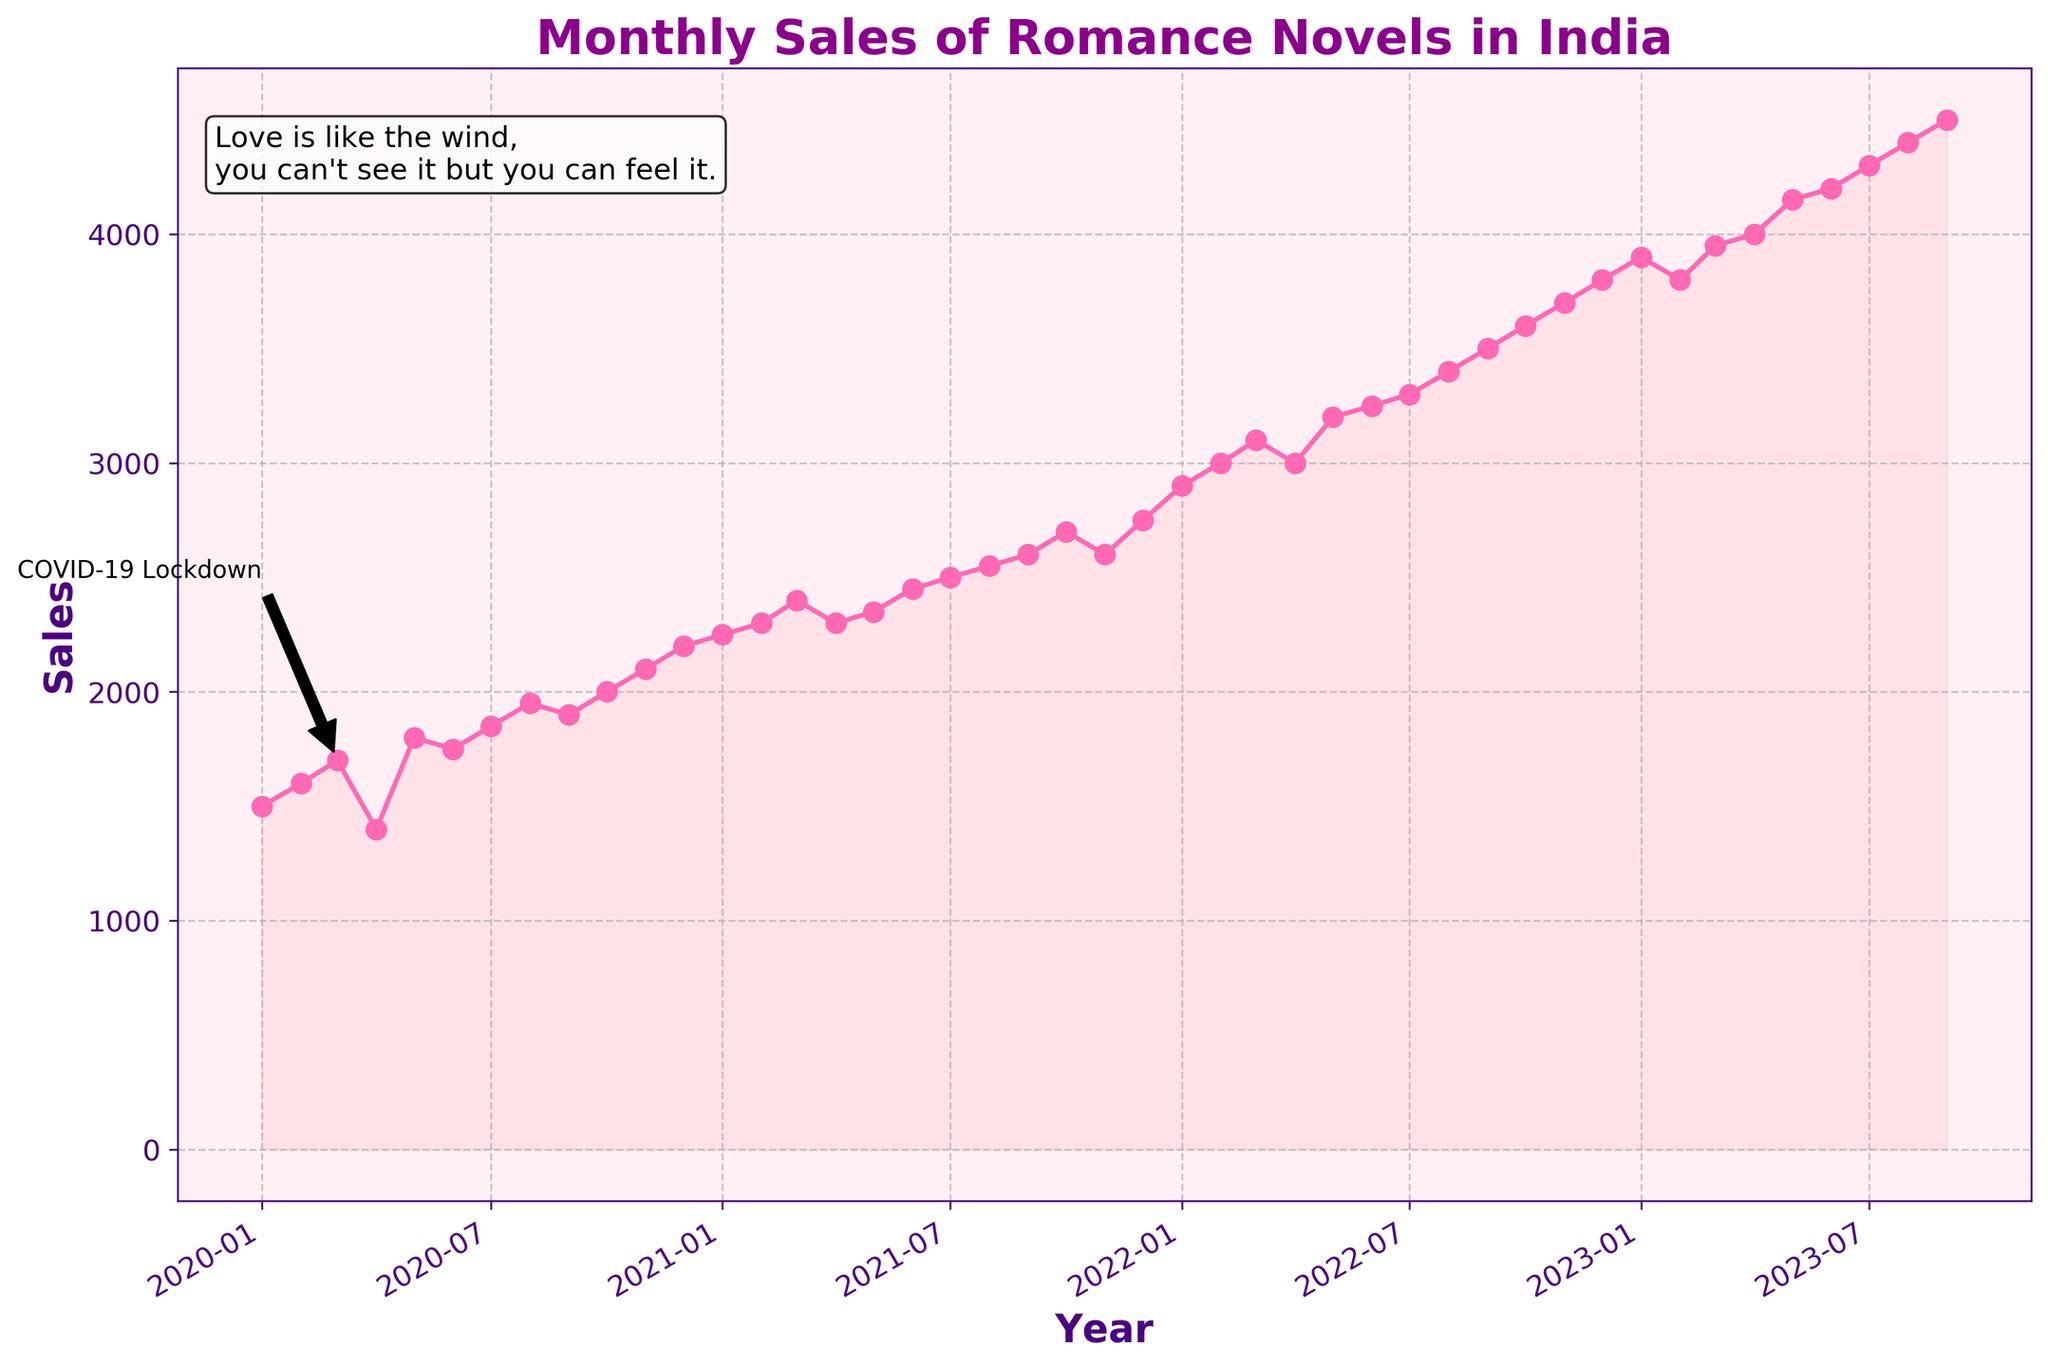What is the title of the plot? The title of the plot is prominently displayed at the top and in bold. By looking at the figure, you can see that it reads "Monthly Sales of Romance Novels in India".
Answer: Monthly Sales of Romance Novels in India Which time period does the plot cover? You can determine the time period by looking at the x-axis, which represents time months. The plot starts from January 2020 and goes up to September 2023.
Answer: January 2020 to September 2023 What is the general trend of the sales of romance novels from January 2020 to September 2023? By observing the line plot, you can see it generally trends upwards. Despite some fluctuations, the overall trend is a consistent increase in sales over the given period.
Answer: Upwards How did the sales of romance novels change between March 2020 and April 2020? Looking at the specific data points for March and April 2020, you notice the sales decrease from 1700 in March 2020 to 1400 in April 2020.
Answer: Decreased During which month and year did the sales hit 3000 for the first time? By tracing the datapoints along the y-axis, you find that the sales hit 3000 for the first time in February 2022.
Answer: February 2022 How many months show sales higher than 3000? By counting the months after February 2022 on the x-axis where sales exceed 3000: From March 2022 onwards, there are 19 months with sales higher than 3000.
Answer: 19 Were sales higher in January 2021 or January 2022 and by how much? Compare the sales figures of January 2021 and January 2022 from the plot. January 2021 had 2250 sales while January 2022 had 2900 sales, making January 2022 higher by 650 sales.
Answer: January 2022 by 650 What significant event is annotated in the plot and when did it occur? The plot includes a text annotation and arrow labeled "COVID-19 Lockdown," pointing approximately at March 2020. This indicates the lockdown happened around this time.
Answer: COVID-19 Lockdown in March 2020 By how much did sales increase from December 2022 to January 2023? Note the sales figures for December 2022 and January 2023; they are 3800 and 3900, respectively. The difference is 3900 - 3800 = 100.
Answer: 100 